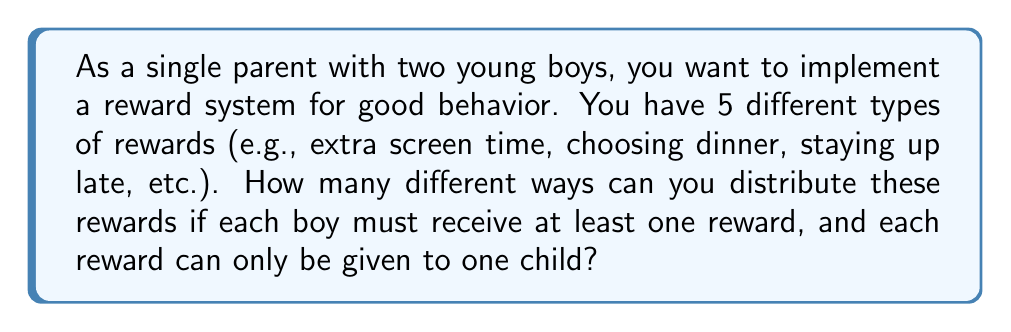Can you answer this question? Let's approach this step-by-step using the concept of distributing distinct objects into distinct boxes.

1) We have 5 distinct rewards and 2 distinct children (boys).

2) Each boy must receive at least one reward, so we can't give all rewards to one child.

3) We can use the concept of complementary counting. Let's count the total number of ways to distribute the rewards, then subtract the invalid cases.

4) Total number of ways to distribute 5 distinct rewards to 2 children:
   $$2^5 = 32$$
   This is because each reward has 2 choices (given to boy 1 or boy 2).

5) Invalid cases:
   - All rewards given to boy 1: 1 way
   - All rewards given to boy 2: 1 way

6) Therefore, the number of valid distributions is:
   $$32 - 2 = 30$$

However, we can also solve this directly:

7) Let's count the ways where boy 1 gets $k$ rewards and boy 2 gets $5-k$ rewards, where $1 \leq k \leq 4$:

   - Boy 1 gets 1 reward, Boy 2 gets 4: $\binom{5}{1} = 5$ ways
   - Boy 1 gets 2 rewards, Boy 2 gets 3: $\binom{5}{2} = 10$ ways
   - Boy 1 gets 3 rewards, Boy 2 gets 2: $\binom{5}{3} = 10$ ways
   - Boy 1 gets 4 rewards, Boy 2 gets 1: $\binom{5}{4} = 5$ ways

8) The total number of ways is the sum of these:
   $$5 + 10 + 10 + 5 = 30$$

This confirms our earlier result.
Answer: There are 30 different ways to distribute the rewards. 